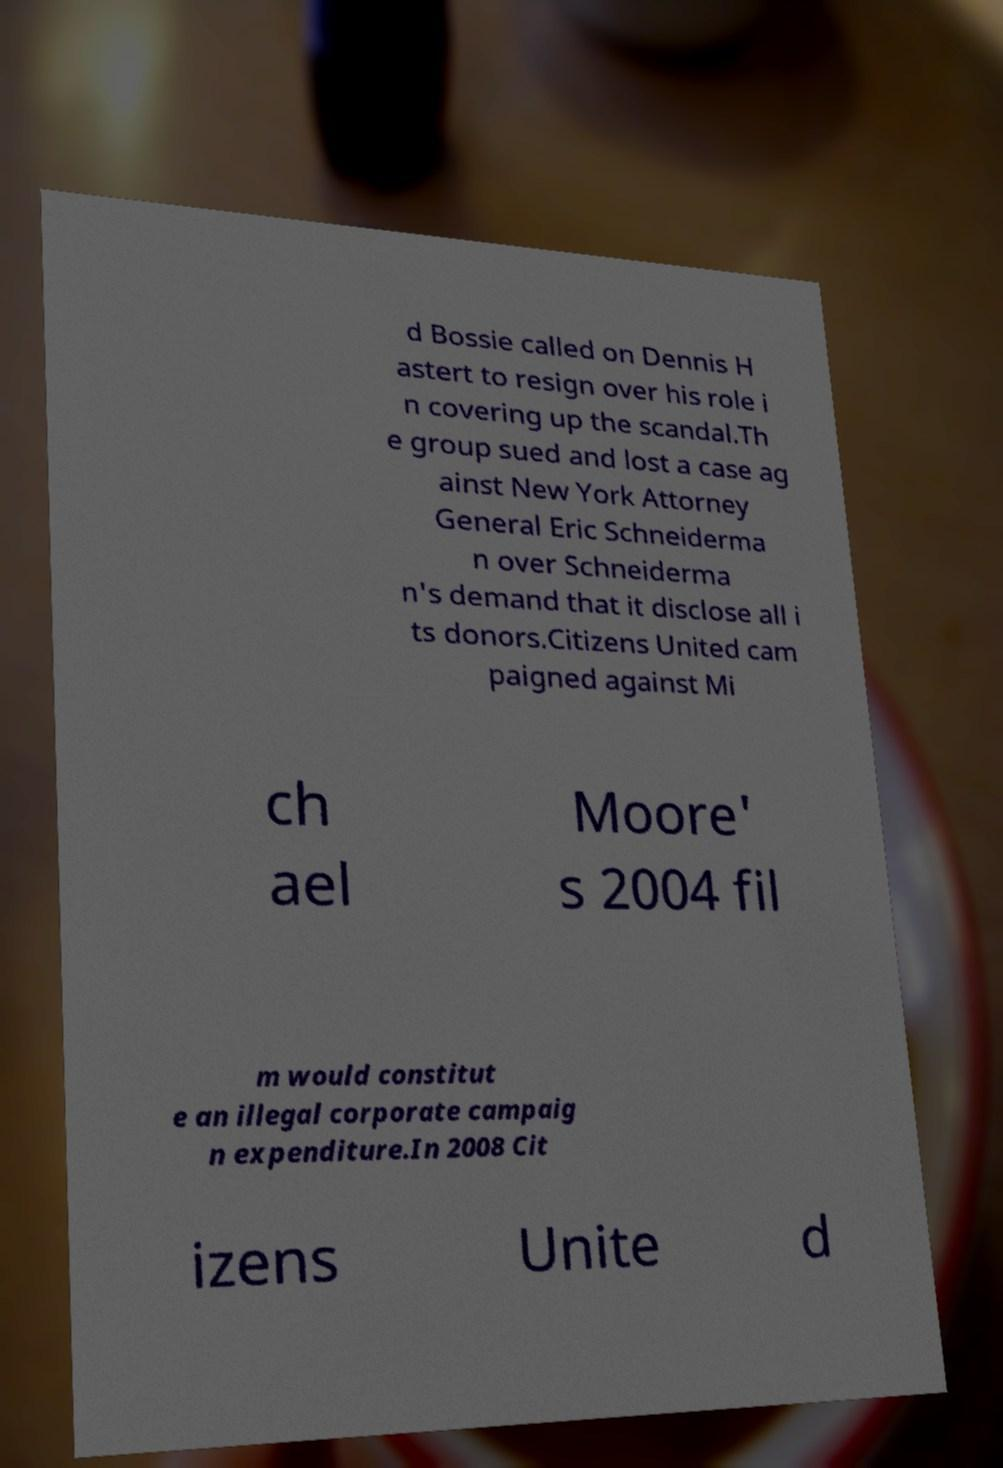Can you read and provide the text displayed in the image?This photo seems to have some interesting text. Can you extract and type it out for me? d Bossie called on Dennis H astert to resign over his role i n covering up the scandal.Th e group sued and lost a case ag ainst New York Attorney General Eric Schneiderma n over Schneiderma n's demand that it disclose all i ts donors.Citizens United cam paigned against Mi ch ael Moore' s 2004 fil m would constitut e an illegal corporate campaig n expenditure.In 2008 Cit izens Unite d 